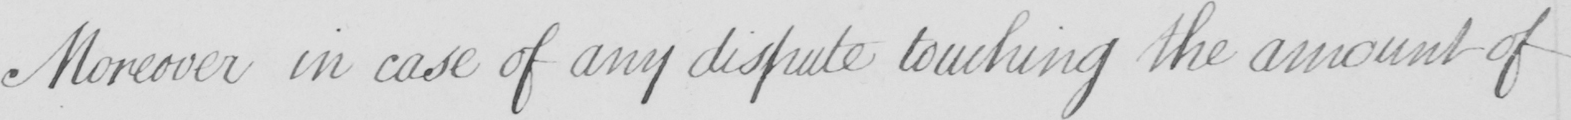Please provide the text content of this handwritten line. Moreover in case of any dispute touching the amount of 